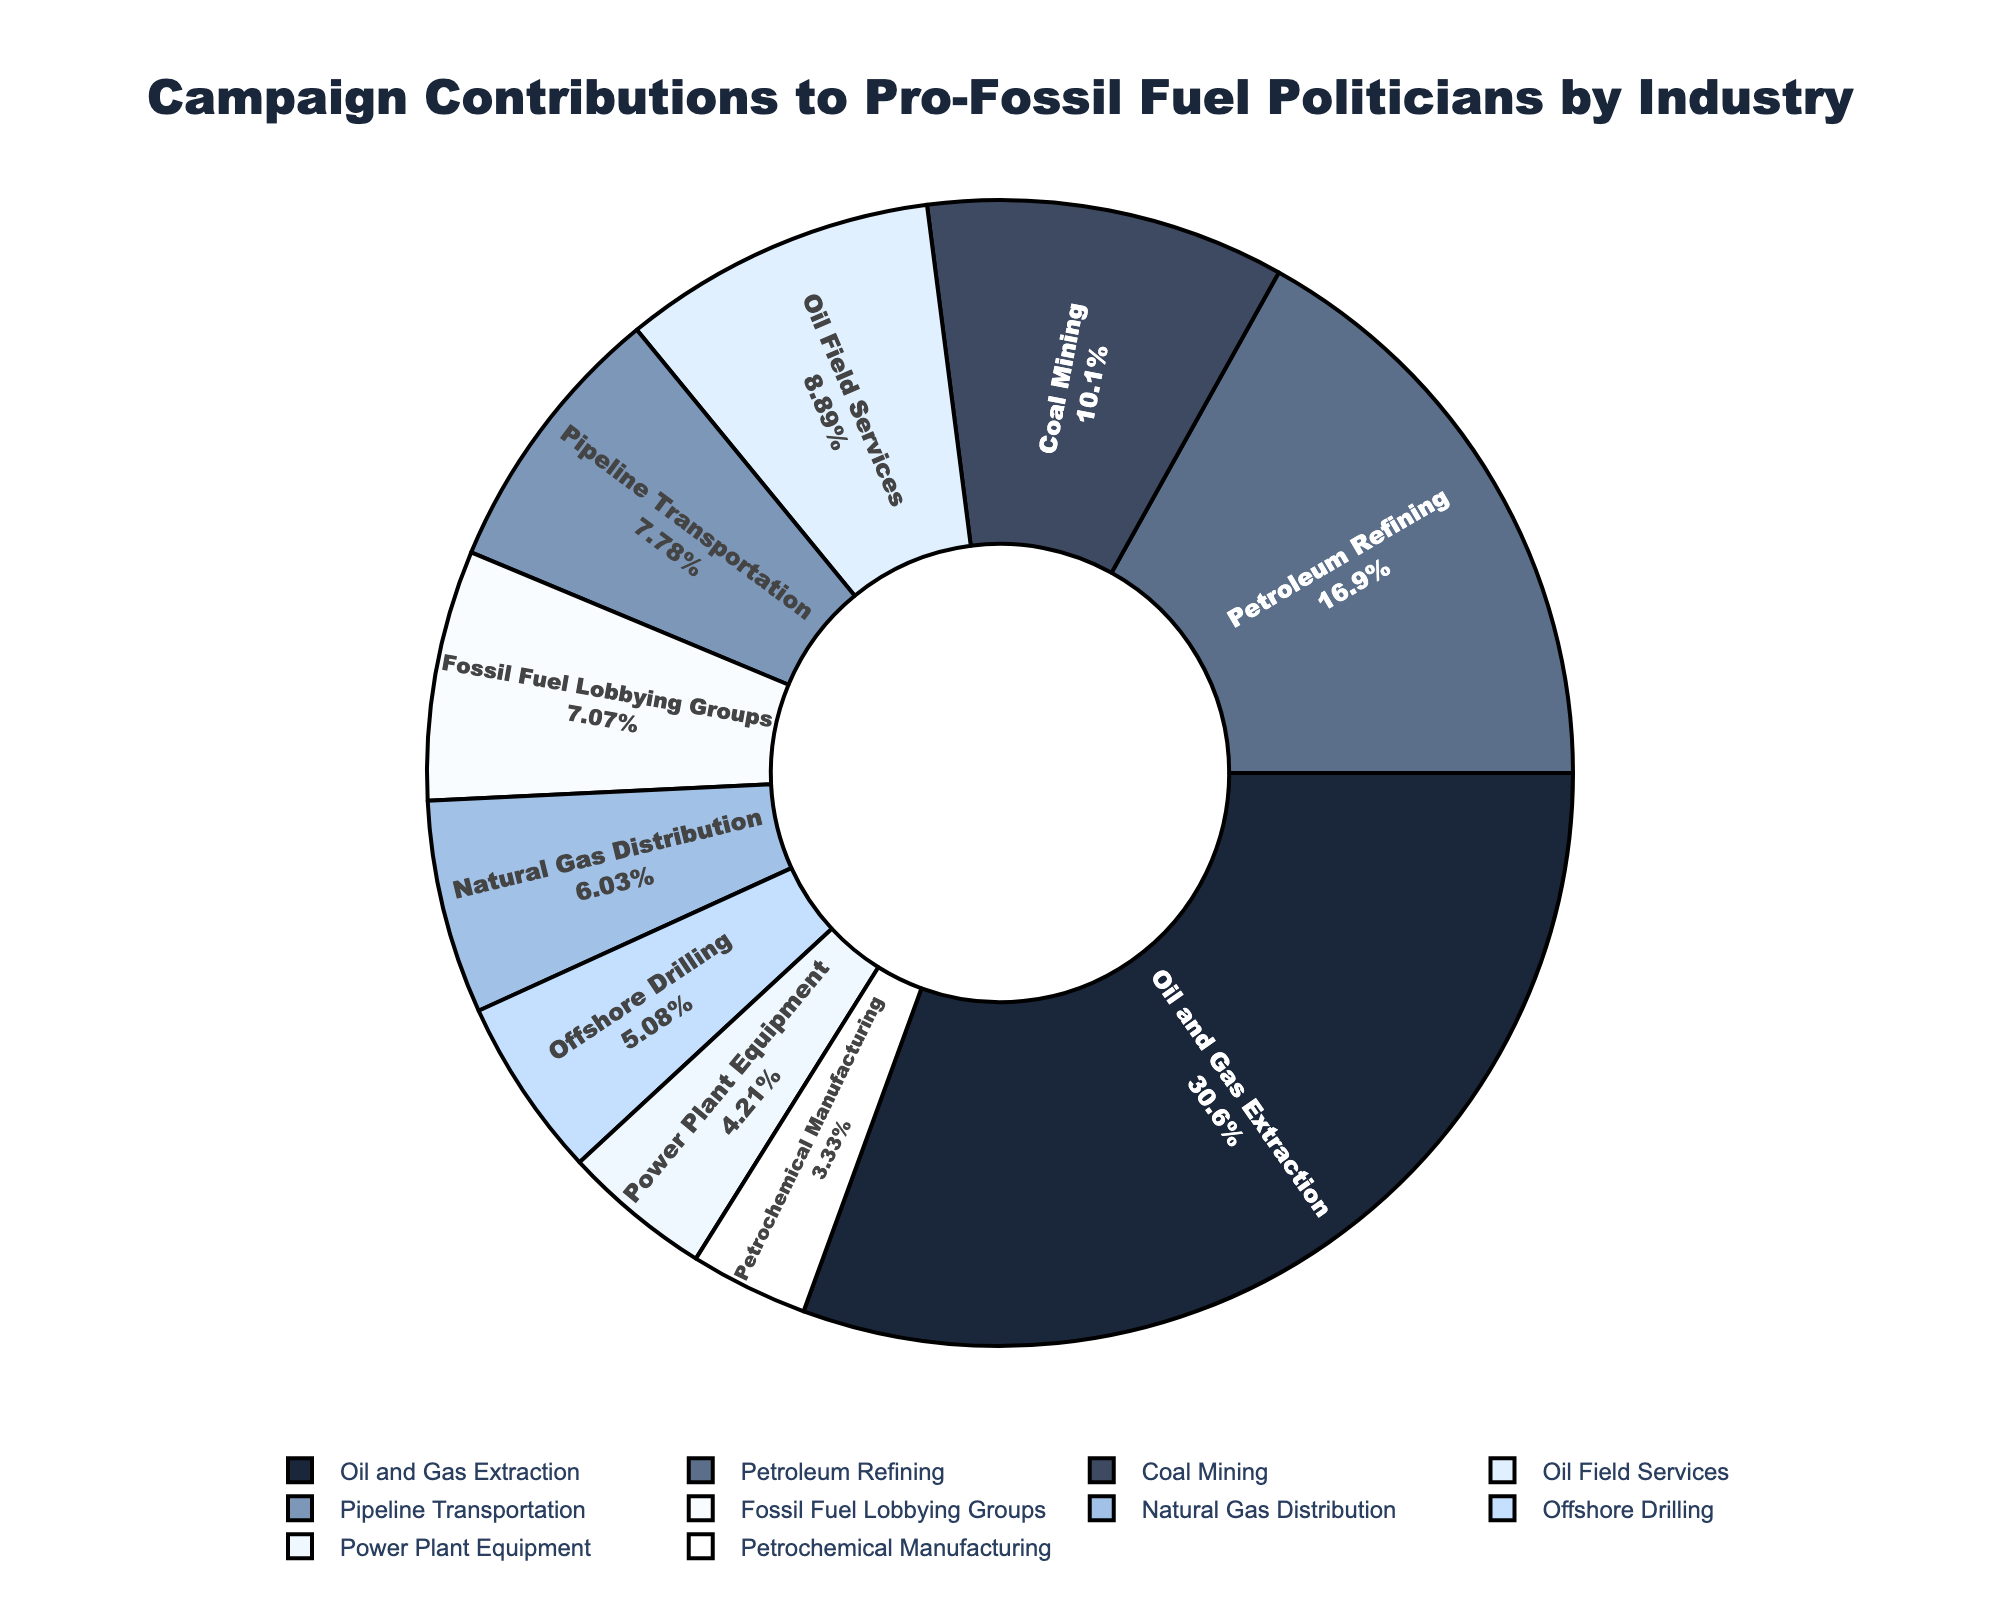What's the largest contribution by industry? The largest contribution is represented by the biggest portion of the pie chart. The segment labeled "Oil and Gas Extraction" is visually the largest.
Answer: $38,500,000 What's the total contribution from Oil Field Services and Petroleum Refining? To find the total, add the contributions from both industries. Oil Field Services contributed $11,200,000 and Petroleum Refining contributed $21,300,000. Therefore, $11,200,000 + $21,300,000 = $32,500,000.
Answer: $32,500,000 Which industry has the smallest contribution? The smallest contribution can be identified by the smallest segment in the pie chart. The industry labeled "Petrochemical Manufacturing" is visually the smallest segment.
Answer: $4,200,000 Is the contribution from Coal Mining more or less than half of Oil and Gas Extraction? To determine this, find half of the contribution from Oil and Gas Extraction: $38,500,000 / 2 = $19,250,000. The contribution from Coal Mining is $12,750,000, which is less than $19,250,000.
Answer: Less What's the cumulative contribution of the industries related to natural gas (Pipeline Transportation and Natural Gas Distribution)? To find the cumulative contribution, sum the contributions from Pipeline Transportation and Natural Gas Distribution. Pipeline Transportation contributed $9,800,000 and Natural Gas Distribution contributed $7,600,000. Therefore, $9,800,000 + $7,600,000 = $17,400,000.
Answer: $17,400,000 How does the contribution from Fossil Fuel Lobbying Groups compare to Offshore Drilling? Compare the contribution amounts of the two industries directly from the chart. Fossil Fuel Lobbying Groups contributed $8,900,000 and Offshore Drilling contributed $6,400,000. Therefore, Fossil Fuel Lobbying Groups contributed more.
Answer: More What's the average contribution amount across all industries? First, sum all the contributions and then divide by the number of industries. Sum: $38,500,000 + $12,750,000 + $21,300,000 + $9,800,000 + $7,600,000 + $6,400,000 + $11,200,000 + $5,300,000 + $8,900,000 + $4,200,000 = $125,950,000. There are 10 industries. Therefore, the average is $125,950,000 / 10 = $12,595,000.
Answer: $12,595,000 Which two industries combined contribute the same amount as Oil and Gas Extraction? To find this, look for two industries whose combined contributions equal $38,500,000. Combine Petroleum Refining ($21,300,000) and Oil Field Services ($11,200,000) first: $21,300,000 + $11,200,000 = $32,500,000, which is not equal to $38,500,000. Try Petroleum Refining and Pipeline Transportation: $21,300,000 + $9,800,000 = $31,100,000. Another attempt, Coal Mining ($12,750,000) and Petroleum Refining ($21,300,000): $12,750,000 + $21,300,000 = $34,050,000. Try Fossil Fuel Lobbying Groups ($8,900,000) and Power Plant Equipment ($5,300,000): $8,900,000 + $5,300,000 = $14,200,000, then add Oil Field Services ($11,200,000) for a total of $11,200,000 + $8,900,000 + $5,300,000 = $25,400,000. No two clear industries directly match.
Answer: None 